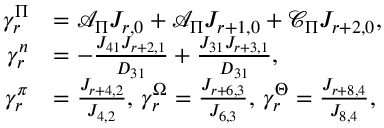Convert formula to latex. <formula><loc_0><loc_0><loc_500><loc_500>\begin{array} { r l } { \gamma _ { r } ^ { \Pi } } & { = \mathcal { A } _ { \Pi } J _ { r , 0 } + \mathcal { A } _ { \Pi } J _ { r + 1 , 0 } + \mathcal { C } _ { \Pi } J _ { r + 2 , 0 } , } \\ { \gamma _ { r } ^ { n } } & { = - \frac { J _ { 4 1 } J _ { r + 2 , 1 } } { D _ { 3 1 } } + \frac { J _ { 3 1 } J _ { r + 3 , 1 } } { D _ { 3 1 } } , } \\ { \gamma _ { r } ^ { \pi } } & { = \frac { J _ { r + 4 , 2 } } { J _ { 4 , 2 } } , \, \gamma _ { r } ^ { \Omega } = \frac { J _ { r + 6 , 3 } } { J _ { 6 , 3 } } , \, \gamma _ { r } ^ { \Theta } = \frac { J _ { r + 8 , 4 } } { J _ { 8 , 4 } } , } \end{array}</formula> 